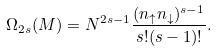<formula> <loc_0><loc_0><loc_500><loc_500>\Omega _ { 2 s } ( M ) = N ^ { 2 s - 1 } \frac { ( n _ { \uparrow } n _ { \downarrow } ) ^ { s - 1 } } { s ! ( s - 1 ) ! } .</formula> 